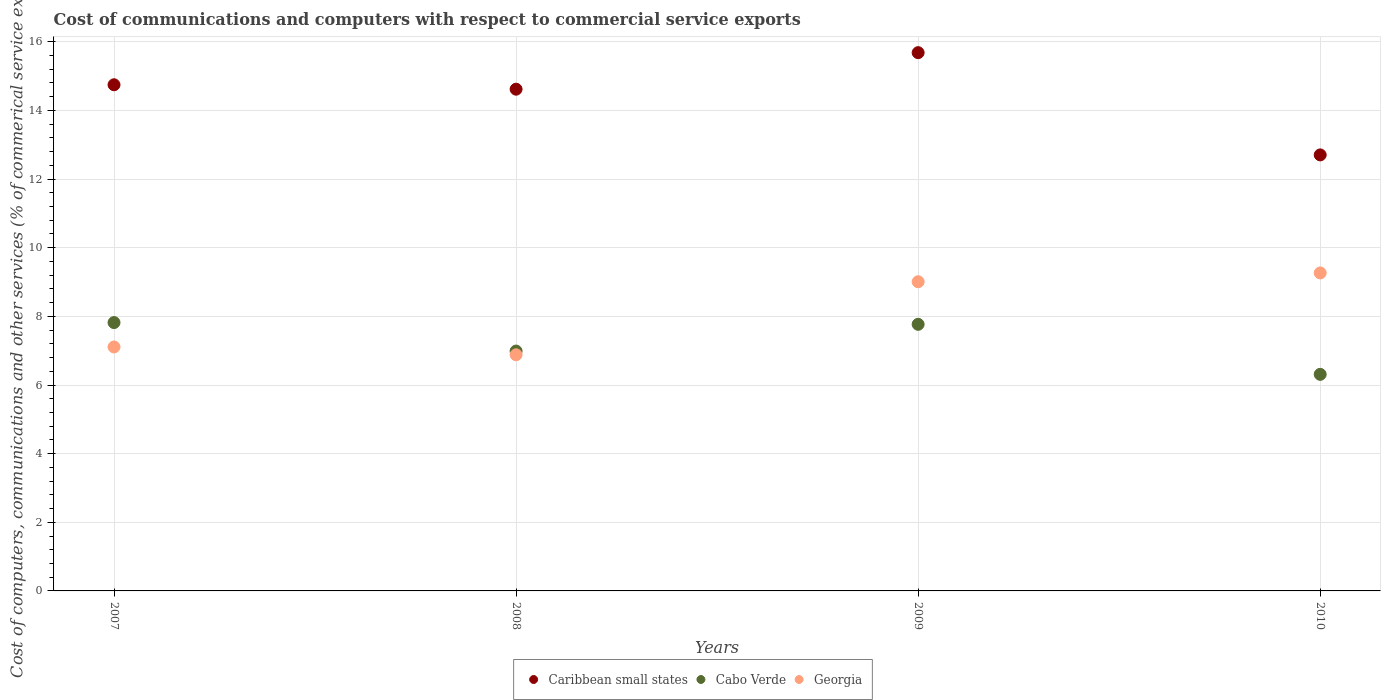How many different coloured dotlines are there?
Make the answer very short. 3. What is the cost of communications and computers in Cabo Verde in 2010?
Your answer should be compact. 6.31. Across all years, what is the maximum cost of communications and computers in Georgia?
Offer a very short reply. 9.27. Across all years, what is the minimum cost of communications and computers in Caribbean small states?
Make the answer very short. 12.7. In which year was the cost of communications and computers in Caribbean small states maximum?
Your answer should be very brief. 2009. In which year was the cost of communications and computers in Caribbean small states minimum?
Offer a very short reply. 2010. What is the total cost of communications and computers in Caribbean small states in the graph?
Offer a terse response. 57.76. What is the difference between the cost of communications and computers in Caribbean small states in 2008 and that in 2009?
Provide a succinct answer. -1.06. What is the difference between the cost of communications and computers in Georgia in 2008 and the cost of communications and computers in Caribbean small states in 2009?
Provide a succinct answer. -8.8. What is the average cost of communications and computers in Cabo Verde per year?
Give a very brief answer. 7.22. In the year 2010, what is the difference between the cost of communications and computers in Cabo Verde and cost of communications and computers in Georgia?
Provide a succinct answer. -2.96. In how many years, is the cost of communications and computers in Cabo Verde greater than 8.4 %?
Offer a terse response. 0. What is the ratio of the cost of communications and computers in Caribbean small states in 2008 to that in 2010?
Your answer should be very brief. 1.15. Is the cost of communications and computers in Caribbean small states in 2008 less than that in 2010?
Keep it short and to the point. No. Is the difference between the cost of communications and computers in Cabo Verde in 2007 and 2008 greater than the difference between the cost of communications and computers in Georgia in 2007 and 2008?
Ensure brevity in your answer.  Yes. What is the difference between the highest and the second highest cost of communications and computers in Georgia?
Keep it short and to the point. 0.26. What is the difference between the highest and the lowest cost of communications and computers in Georgia?
Your answer should be very brief. 2.38. Is it the case that in every year, the sum of the cost of communications and computers in Cabo Verde and cost of communications and computers in Caribbean small states  is greater than the cost of communications and computers in Georgia?
Offer a very short reply. Yes. How many dotlines are there?
Provide a short and direct response. 3. How many years are there in the graph?
Your answer should be compact. 4. What is the difference between two consecutive major ticks on the Y-axis?
Offer a very short reply. 2. Are the values on the major ticks of Y-axis written in scientific E-notation?
Your answer should be compact. No. Does the graph contain any zero values?
Provide a short and direct response. No. Where does the legend appear in the graph?
Your response must be concise. Bottom center. How many legend labels are there?
Offer a terse response. 3. How are the legend labels stacked?
Give a very brief answer. Horizontal. What is the title of the graph?
Ensure brevity in your answer.  Cost of communications and computers with respect to commercial service exports. What is the label or title of the X-axis?
Your answer should be compact. Years. What is the label or title of the Y-axis?
Offer a very short reply. Cost of computers, communications and other services (% of commerical service exports). What is the Cost of computers, communications and other services (% of commerical service exports) in Caribbean small states in 2007?
Make the answer very short. 14.75. What is the Cost of computers, communications and other services (% of commerical service exports) of Cabo Verde in 2007?
Offer a terse response. 7.82. What is the Cost of computers, communications and other services (% of commerical service exports) of Georgia in 2007?
Your response must be concise. 7.11. What is the Cost of computers, communications and other services (% of commerical service exports) in Caribbean small states in 2008?
Ensure brevity in your answer.  14.62. What is the Cost of computers, communications and other services (% of commerical service exports) in Cabo Verde in 2008?
Keep it short and to the point. 6.99. What is the Cost of computers, communications and other services (% of commerical service exports) in Georgia in 2008?
Provide a short and direct response. 6.88. What is the Cost of computers, communications and other services (% of commerical service exports) of Caribbean small states in 2009?
Keep it short and to the point. 15.68. What is the Cost of computers, communications and other services (% of commerical service exports) of Cabo Verde in 2009?
Your answer should be very brief. 7.77. What is the Cost of computers, communications and other services (% of commerical service exports) of Georgia in 2009?
Provide a succinct answer. 9.01. What is the Cost of computers, communications and other services (% of commerical service exports) in Caribbean small states in 2010?
Your answer should be compact. 12.7. What is the Cost of computers, communications and other services (% of commerical service exports) in Cabo Verde in 2010?
Your answer should be very brief. 6.31. What is the Cost of computers, communications and other services (% of commerical service exports) in Georgia in 2010?
Provide a succinct answer. 9.27. Across all years, what is the maximum Cost of computers, communications and other services (% of commerical service exports) of Caribbean small states?
Ensure brevity in your answer.  15.68. Across all years, what is the maximum Cost of computers, communications and other services (% of commerical service exports) in Cabo Verde?
Make the answer very short. 7.82. Across all years, what is the maximum Cost of computers, communications and other services (% of commerical service exports) of Georgia?
Offer a very short reply. 9.27. Across all years, what is the minimum Cost of computers, communications and other services (% of commerical service exports) in Caribbean small states?
Offer a very short reply. 12.7. Across all years, what is the minimum Cost of computers, communications and other services (% of commerical service exports) of Cabo Verde?
Give a very brief answer. 6.31. Across all years, what is the minimum Cost of computers, communications and other services (% of commerical service exports) in Georgia?
Offer a terse response. 6.88. What is the total Cost of computers, communications and other services (% of commerical service exports) in Caribbean small states in the graph?
Provide a succinct answer. 57.76. What is the total Cost of computers, communications and other services (% of commerical service exports) in Cabo Verde in the graph?
Offer a terse response. 28.89. What is the total Cost of computers, communications and other services (% of commerical service exports) in Georgia in the graph?
Offer a terse response. 32.26. What is the difference between the Cost of computers, communications and other services (% of commerical service exports) of Caribbean small states in 2007 and that in 2008?
Your answer should be compact. 0.13. What is the difference between the Cost of computers, communications and other services (% of commerical service exports) in Cabo Verde in 2007 and that in 2008?
Provide a short and direct response. 0.83. What is the difference between the Cost of computers, communications and other services (% of commerical service exports) of Georgia in 2007 and that in 2008?
Make the answer very short. 0.23. What is the difference between the Cost of computers, communications and other services (% of commerical service exports) of Caribbean small states in 2007 and that in 2009?
Offer a very short reply. -0.94. What is the difference between the Cost of computers, communications and other services (% of commerical service exports) in Cabo Verde in 2007 and that in 2009?
Ensure brevity in your answer.  0.05. What is the difference between the Cost of computers, communications and other services (% of commerical service exports) in Georgia in 2007 and that in 2009?
Keep it short and to the point. -1.9. What is the difference between the Cost of computers, communications and other services (% of commerical service exports) of Caribbean small states in 2007 and that in 2010?
Keep it short and to the point. 2.04. What is the difference between the Cost of computers, communications and other services (% of commerical service exports) in Cabo Verde in 2007 and that in 2010?
Make the answer very short. 1.51. What is the difference between the Cost of computers, communications and other services (% of commerical service exports) in Georgia in 2007 and that in 2010?
Offer a very short reply. -2.16. What is the difference between the Cost of computers, communications and other services (% of commerical service exports) in Caribbean small states in 2008 and that in 2009?
Your answer should be very brief. -1.06. What is the difference between the Cost of computers, communications and other services (% of commerical service exports) of Cabo Verde in 2008 and that in 2009?
Give a very brief answer. -0.78. What is the difference between the Cost of computers, communications and other services (% of commerical service exports) in Georgia in 2008 and that in 2009?
Keep it short and to the point. -2.13. What is the difference between the Cost of computers, communications and other services (% of commerical service exports) in Caribbean small states in 2008 and that in 2010?
Make the answer very short. 1.91. What is the difference between the Cost of computers, communications and other services (% of commerical service exports) in Cabo Verde in 2008 and that in 2010?
Your response must be concise. 0.68. What is the difference between the Cost of computers, communications and other services (% of commerical service exports) of Georgia in 2008 and that in 2010?
Keep it short and to the point. -2.38. What is the difference between the Cost of computers, communications and other services (% of commerical service exports) of Caribbean small states in 2009 and that in 2010?
Keep it short and to the point. 2.98. What is the difference between the Cost of computers, communications and other services (% of commerical service exports) in Cabo Verde in 2009 and that in 2010?
Offer a terse response. 1.46. What is the difference between the Cost of computers, communications and other services (% of commerical service exports) in Georgia in 2009 and that in 2010?
Your answer should be compact. -0.26. What is the difference between the Cost of computers, communications and other services (% of commerical service exports) of Caribbean small states in 2007 and the Cost of computers, communications and other services (% of commerical service exports) of Cabo Verde in 2008?
Your answer should be compact. 7.76. What is the difference between the Cost of computers, communications and other services (% of commerical service exports) of Caribbean small states in 2007 and the Cost of computers, communications and other services (% of commerical service exports) of Georgia in 2008?
Offer a very short reply. 7.87. What is the difference between the Cost of computers, communications and other services (% of commerical service exports) in Cabo Verde in 2007 and the Cost of computers, communications and other services (% of commerical service exports) in Georgia in 2008?
Your answer should be compact. 0.94. What is the difference between the Cost of computers, communications and other services (% of commerical service exports) in Caribbean small states in 2007 and the Cost of computers, communications and other services (% of commerical service exports) in Cabo Verde in 2009?
Offer a terse response. 6.98. What is the difference between the Cost of computers, communications and other services (% of commerical service exports) in Caribbean small states in 2007 and the Cost of computers, communications and other services (% of commerical service exports) in Georgia in 2009?
Give a very brief answer. 5.74. What is the difference between the Cost of computers, communications and other services (% of commerical service exports) in Cabo Verde in 2007 and the Cost of computers, communications and other services (% of commerical service exports) in Georgia in 2009?
Your answer should be very brief. -1.19. What is the difference between the Cost of computers, communications and other services (% of commerical service exports) in Caribbean small states in 2007 and the Cost of computers, communications and other services (% of commerical service exports) in Cabo Verde in 2010?
Offer a very short reply. 8.44. What is the difference between the Cost of computers, communications and other services (% of commerical service exports) in Caribbean small states in 2007 and the Cost of computers, communications and other services (% of commerical service exports) in Georgia in 2010?
Offer a terse response. 5.48. What is the difference between the Cost of computers, communications and other services (% of commerical service exports) of Cabo Verde in 2007 and the Cost of computers, communications and other services (% of commerical service exports) of Georgia in 2010?
Ensure brevity in your answer.  -1.45. What is the difference between the Cost of computers, communications and other services (% of commerical service exports) in Caribbean small states in 2008 and the Cost of computers, communications and other services (% of commerical service exports) in Cabo Verde in 2009?
Make the answer very short. 6.85. What is the difference between the Cost of computers, communications and other services (% of commerical service exports) in Caribbean small states in 2008 and the Cost of computers, communications and other services (% of commerical service exports) in Georgia in 2009?
Your response must be concise. 5.61. What is the difference between the Cost of computers, communications and other services (% of commerical service exports) in Cabo Verde in 2008 and the Cost of computers, communications and other services (% of commerical service exports) in Georgia in 2009?
Your answer should be very brief. -2.02. What is the difference between the Cost of computers, communications and other services (% of commerical service exports) in Caribbean small states in 2008 and the Cost of computers, communications and other services (% of commerical service exports) in Cabo Verde in 2010?
Ensure brevity in your answer.  8.31. What is the difference between the Cost of computers, communications and other services (% of commerical service exports) of Caribbean small states in 2008 and the Cost of computers, communications and other services (% of commerical service exports) of Georgia in 2010?
Provide a succinct answer. 5.35. What is the difference between the Cost of computers, communications and other services (% of commerical service exports) of Cabo Verde in 2008 and the Cost of computers, communications and other services (% of commerical service exports) of Georgia in 2010?
Offer a very short reply. -2.28. What is the difference between the Cost of computers, communications and other services (% of commerical service exports) of Caribbean small states in 2009 and the Cost of computers, communications and other services (% of commerical service exports) of Cabo Verde in 2010?
Keep it short and to the point. 9.37. What is the difference between the Cost of computers, communications and other services (% of commerical service exports) of Caribbean small states in 2009 and the Cost of computers, communications and other services (% of commerical service exports) of Georgia in 2010?
Offer a very short reply. 6.42. What is the difference between the Cost of computers, communications and other services (% of commerical service exports) in Cabo Verde in 2009 and the Cost of computers, communications and other services (% of commerical service exports) in Georgia in 2010?
Provide a short and direct response. -1.5. What is the average Cost of computers, communications and other services (% of commerical service exports) in Caribbean small states per year?
Offer a very short reply. 14.44. What is the average Cost of computers, communications and other services (% of commerical service exports) of Cabo Verde per year?
Make the answer very short. 7.22. What is the average Cost of computers, communications and other services (% of commerical service exports) of Georgia per year?
Provide a succinct answer. 8.07. In the year 2007, what is the difference between the Cost of computers, communications and other services (% of commerical service exports) of Caribbean small states and Cost of computers, communications and other services (% of commerical service exports) of Cabo Verde?
Offer a terse response. 6.93. In the year 2007, what is the difference between the Cost of computers, communications and other services (% of commerical service exports) in Caribbean small states and Cost of computers, communications and other services (% of commerical service exports) in Georgia?
Your response must be concise. 7.64. In the year 2007, what is the difference between the Cost of computers, communications and other services (% of commerical service exports) in Cabo Verde and Cost of computers, communications and other services (% of commerical service exports) in Georgia?
Make the answer very short. 0.71. In the year 2008, what is the difference between the Cost of computers, communications and other services (% of commerical service exports) of Caribbean small states and Cost of computers, communications and other services (% of commerical service exports) of Cabo Verde?
Give a very brief answer. 7.63. In the year 2008, what is the difference between the Cost of computers, communications and other services (% of commerical service exports) of Caribbean small states and Cost of computers, communications and other services (% of commerical service exports) of Georgia?
Your answer should be very brief. 7.74. In the year 2008, what is the difference between the Cost of computers, communications and other services (% of commerical service exports) in Cabo Verde and Cost of computers, communications and other services (% of commerical service exports) in Georgia?
Offer a terse response. 0.11. In the year 2009, what is the difference between the Cost of computers, communications and other services (% of commerical service exports) of Caribbean small states and Cost of computers, communications and other services (% of commerical service exports) of Cabo Verde?
Provide a short and direct response. 7.92. In the year 2009, what is the difference between the Cost of computers, communications and other services (% of commerical service exports) in Caribbean small states and Cost of computers, communications and other services (% of commerical service exports) in Georgia?
Provide a short and direct response. 6.67. In the year 2009, what is the difference between the Cost of computers, communications and other services (% of commerical service exports) of Cabo Verde and Cost of computers, communications and other services (% of commerical service exports) of Georgia?
Ensure brevity in your answer.  -1.24. In the year 2010, what is the difference between the Cost of computers, communications and other services (% of commerical service exports) in Caribbean small states and Cost of computers, communications and other services (% of commerical service exports) in Cabo Verde?
Give a very brief answer. 6.39. In the year 2010, what is the difference between the Cost of computers, communications and other services (% of commerical service exports) in Caribbean small states and Cost of computers, communications and other services (% of commerical service exports) in Georgia?
Ensure brevity in your answer.  3.44. In the year 2010, what is the difference between the Cost of computers, communications and other services (% of commerical service exports) of Cabo Verde and Cost of computers, communications and other services (% of commerical service exports) of Georgia?
Ensure brevity in your answer.  -2.96. What is the ratio of the Cost of computers, communications and other services (% of commerical service exports) in Caribbean small states in 2007 to that in 2008?
Keep it short and to the point. 1.01. What is the ratio of the Cost of computers, communications and other services (% of commerical service exports) of Cabo Verde in 2007 to that in 2008?
Your answer should be very brief. 1.12. What is the ratio of the Cost of computers, communications and other services (% of commerical service exports) in Georgia in 2007 to that in 2008?
Your response must be concise. 1.03. What is the ratio of the Cost of computers, communications and other services (% of commerical service exports) of Caribbean small states in 2007 to that in 2009?
Your response must be concise. 0.94. What is the ratio of the Cost of computers, communications and other services (% of commerical service exports) in Cabo Verde in 2007 to that in 2009?
Offer a very short reply. 1.01. What is the ratio of the Cost of computers, communications and other services (% of commerical service exports) in Georgia in 2007 to that in 2009?
Make the answer very short. 0.79. What is the ratio of the Cost of computers, communications and other services (% of commerical service exports) of Caribbean small states in 2007 to that in 2010?
Your response must be concise. 1.16. What is the ratio of the Cost of computers, communications and other services (% of commerical service exports) of Cabo Verde in 2007 to that in 2010?
Your answer should be very brief. 1.24. What is the ratio of the Cost of computers, communications and other services (% of commerical service exports) in Georgia in 2007 to that in 2010?
Ensure brevity in your answer.  0.77. What is the ratio of the Cost of computers, communications and other services (% of commerical service exports) in Caribbean small states in 2008 to that in 2009?
Your response must be concise. 0.93. What is the ratio of the Cost of computers, communications and other services (% of commerical service exports) in Cabo Verde in 2008 to that in 2009?
Offer a terse response. 0.9. What is the ratio of the Cost of computers, communications and other services (% of commerical service exports) of Georgia in 2008 to that in 2009?
Provide a succinct answer. 0.76. What is the ratio of the Cost of computers, communications and other services (% of commerical service exports) in Caribbean small states in 2008 to that in 2010?
Your answer should be very brief. 1.15. What is the ratio of the Cost of computers, communications and other services (% of commerical service exports) in Cabo Verde in 2008 to that in 2010?
Your answer should be very brief. 1.11. What is the ratio of the Cost of computers, communications and other services (% of commerical service exports) in Georgia in 2008 to that in 2010?
Your answer should be compact. 0.74. What is the ratio of the Cost of computers, communications and other services (% of commerical service exports) of Caribbean small states in 2009 to that in 2010?
Keep it short and to the point. 1.23. What is the ratio of the Cost of computers, communications and other services (% of commerical service exports) in Cabo Verde in 2009 to that in 2010?
Offer a terse response. 1.23. What is the ratio of the Cost of computers, communications and other services (% of commerical service exports) of Georgia in 2009 to that in 2010?
Give a very brief answer. 0.97. What is the difference between the highest and the second highest Cost of computers, communications and other services (% of commerical service exports) in Caribbean small states?
Provide a succinct answer. 0.94. What is the difference between the highest and the second highest Cost of computers, communications and other services (% of commerical service exports) of Cabo Verde?
Offer a terse response. 0.05. What is the difference between the highest and the second highest Cost of computers, communications and other services (% of commerical service exports) in Georgia?
Keep it short and to the point. 0.26. What is the difference between the highest and the lowest Cost of computers, communications and other services (% of commerical service exports) in Caribbean small states?
Make the answer very short. 2.98. What is the difference between the highest and the lowest Cost of computers, communications and other services (% of commerical service exports) in Cabo Verde?
Keep it short and to the point. 1.51. What is the difference between the highest and the lowest Cost of computers, communications and other services (% of commerical service exports) in Georgia?
Offer a terse response. 2.38. 